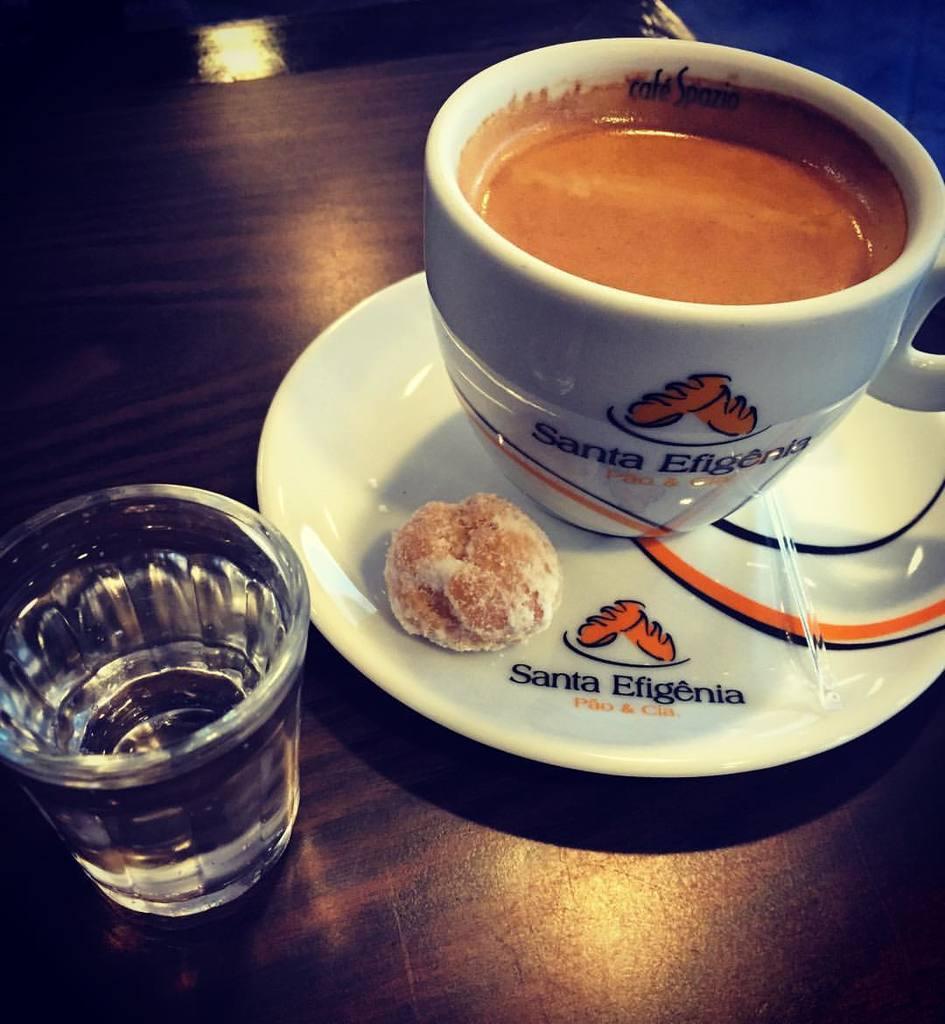In one or two sentences, can you explain what this image depicts? In this image I can see the brown colored table and on it I can see a glass and a white colored plate. On the plate I can see a food item which is brown in color and a white colored cup with brown colored liquid in it. 